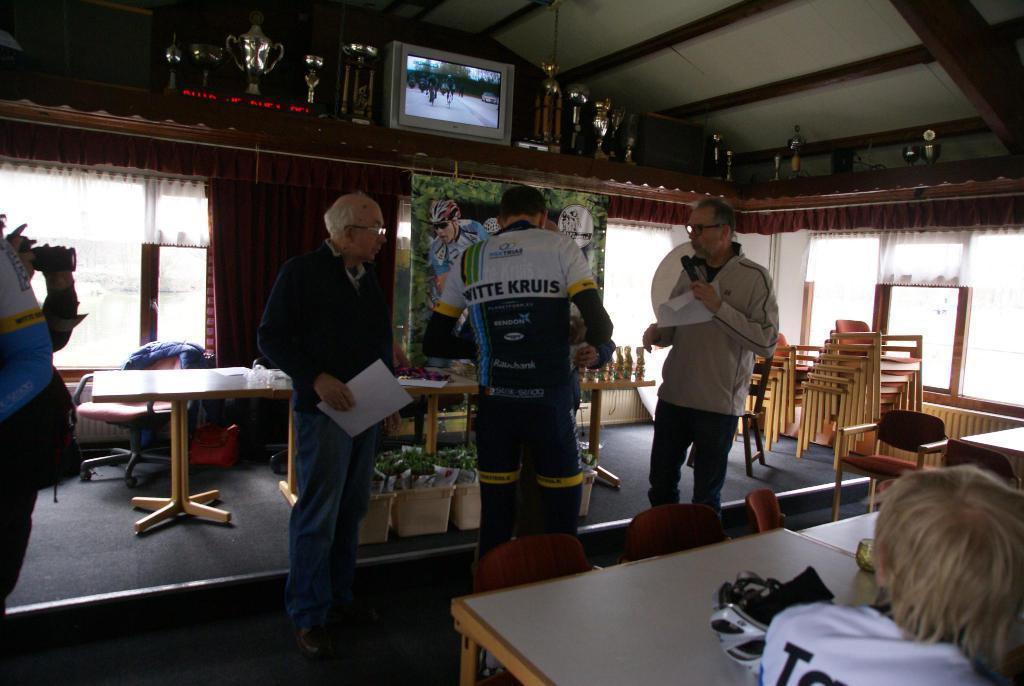Describe this image in one or two sentences. Two men and a sports man are standing. They are looking at something. There are trophies ,photo frames arranged below the roof. There are some chairs at a corner. There are few people around them. 